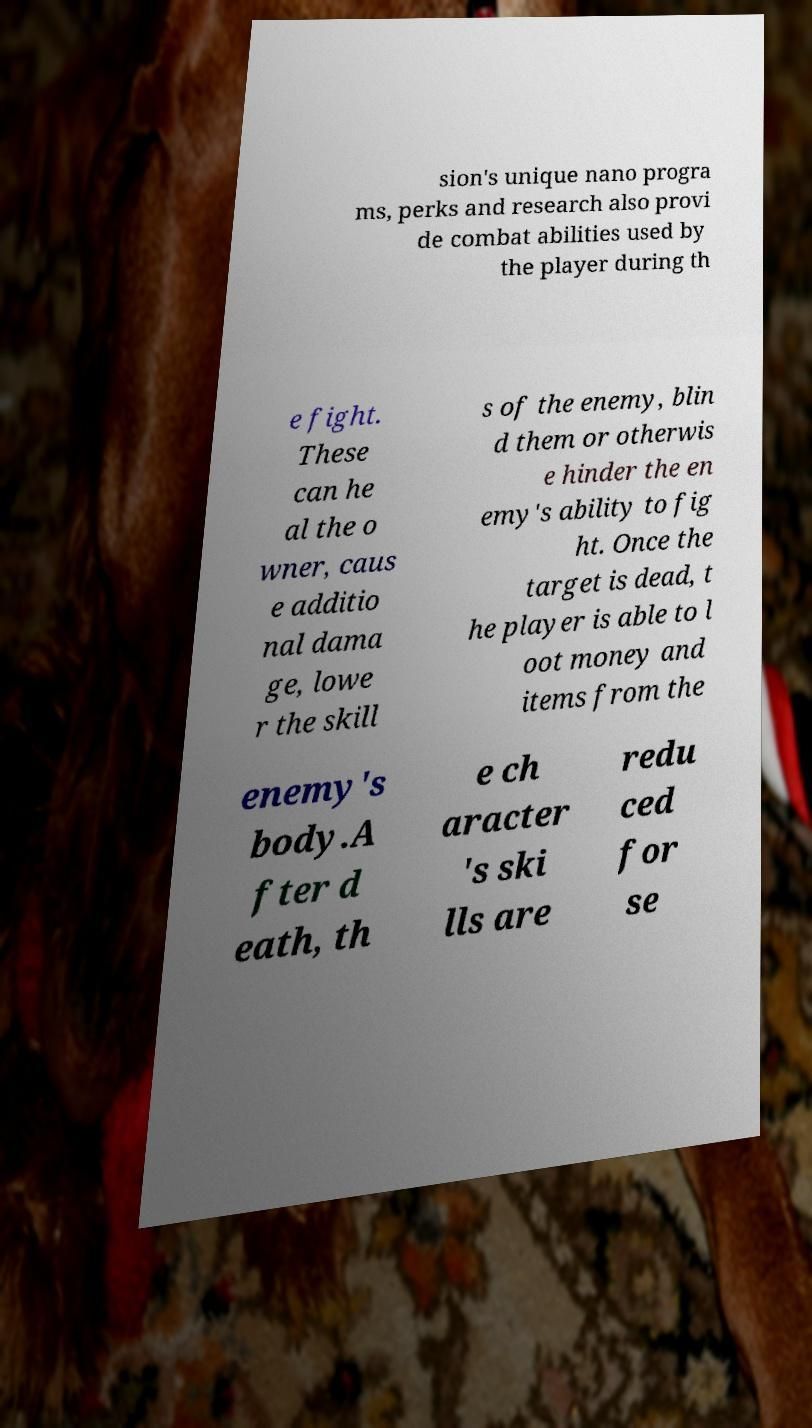Can you read and provide the text displayed in the image?This photo seems to have some interesting text. Can you extract and type it out for me? sion's unique nano progra ms, perks and research also provi de combat abilities used by the player during th e fight. These can he al the o wner, caus e additio nal dama ge, lowe r the skill s of the enemy, blin d them or otherwis e hinder the en emy's ability to fig ht. Once the target is dead, t he player is able to l oot money and items from the enemy's body.A fter d eath, th e ch aracter 's ski lls are redu ced for se 